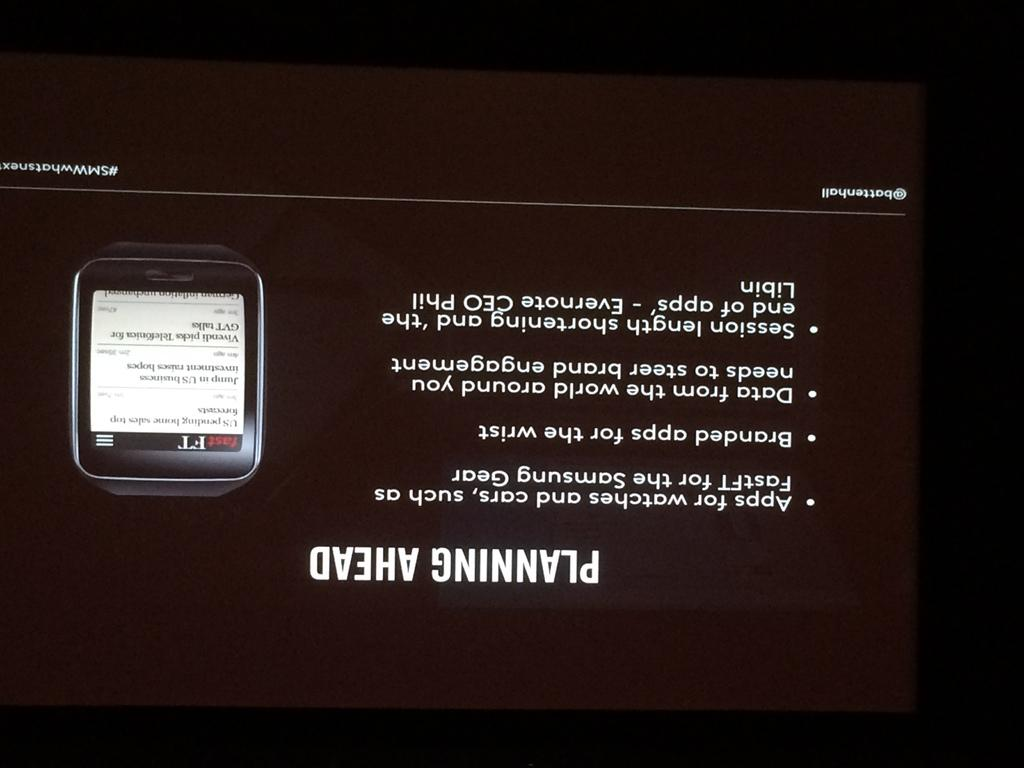Provide a one-sentence caption for the provided image. a picture sign of cell phone service to purchase. 